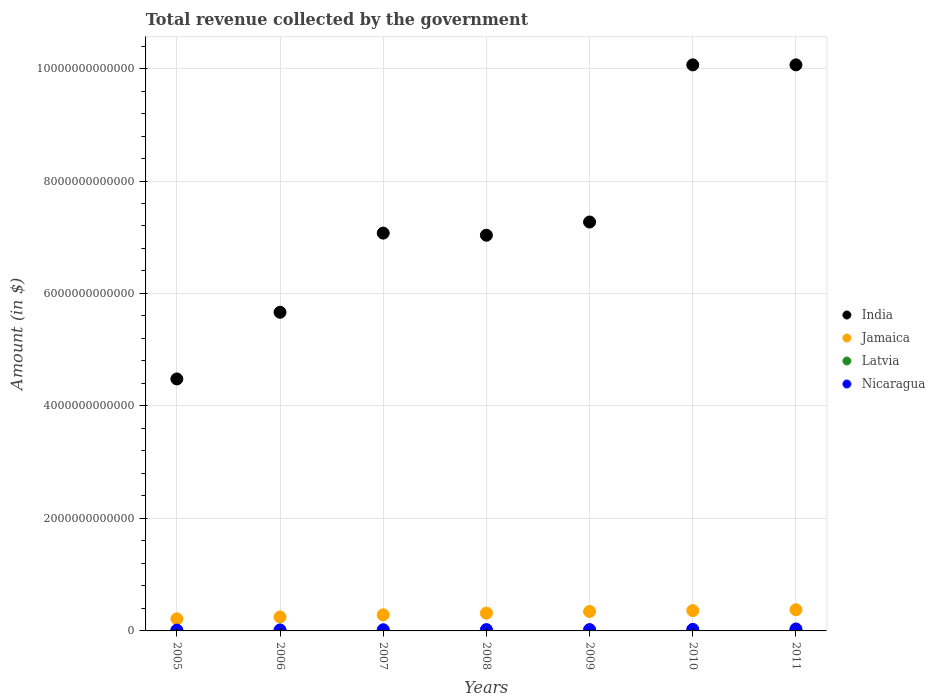Is the number of dotlines equal to the number of legend labels?
Offer a very short reply. Yes. What is the total revenue collected by the government in India in 2007?
Keep it short and to the point. 7.07e+12. Across all years, what is the maximum total revenue collected by the government in India?
Make the answer very short. 1.01e+13. Across all years, what is the minimum total revenue collected by the government in Nicaragua?
Make the answer very short. 1.47e+1. In which year was the total revenue collected by the government in Jamaica maximum?
Your answer should be compact. 2011. In which year was the total revenue collected by the government in India minimum?
Provide a short and direct response. 2005. What is the total total revenue collected by the government in India in the graph?
Ensure brevity in your answer.  5.17e+13. What is the difference between the total revenue collected by the government in Latvia in 2008 and that in 2010?
Provide a succinct answer. 1.04e+09. What is the difference between the total revenue collected by the government in India in 2008 and the total revenue collected by the government in Nicaragua in 2010?
Provide a short and direct response. 7.01e+12. What is the average total revenue collected by the government in India per year?
Ensure brevity in your answer.  7.38e+12. In the year 2011, what is the difference between the total revenue collected by the government in Nicaragua and total revenue collected by the government in Latvia?
Make the answer very short. 3.10e+1. In how many years, is the total revenue collected by the government in Jamaica greater than 6800000000000 $?
Your answer should be very brief. 0. What is the ratio of the total revenue collected by the government in Jamaica in 2005 to that in 2011?
Offer a terse response. 0.57. What is the difference between the highest and the second highest total revenue collected by the government in Nicaragua?
Give a very brief answer. 6.97e+09. What is the difference between the highest and the lowest total revenue collected by the government in India?
Provide a short and direct response. 5.58e+12. In how many years, is the total revenue collected by the government in India greater than the average total revenue collected by the government in India taken over all years?
Offer a very short reply. 2. Is it the case that in every year, the sum of the total revenue collected by the government in Nicaragua and total revenue collected by the government in India  is greater than the total revenue collected by the government in Jamaica?
Ensure brevity in your answer.  Yes. Does the total revenue collected by the government in India monotonically increase over the years?
Ensure brevity in your answer.  No. Is the total revenue collected by the government in Jamaica strictly less than the total revenue collected by the government in Nicaragua over the years?
Provide a short and direct response. No. How many dotlines are there?
Provide a short and direct response. 4. What is the difference between two consecutive major ticks on the Y-axis?
Ensure brevity in your answer.  2.00e+12. Does the graph contain grids?
Ensure brevity in your answer.  Yes. How many legend labels are there?
Offer a very short reply. 4. What is the title of the graph?
Give a very brief answer. Total revenue collected by the government. What is the label or title of the Y-axis?
Ensure brevity in your answer.  Amount (in $). What is the Amount (in $) in India in 2005?
Ensure brevity in your answer.  4.48e+12. What is the Amount (in $) in Jamaica in 2005?
Make the answer very short. 2.15e+11. What is the Amount (in $) in Latvia in 2005?
Your answer should be very brief. 2.38e+09. What is the Amount (in $) in Nicaragua in 2005?
Your answer should be very brief. 1.47e+1. What is the Amount (in $) of India in 2006?
Your answer should be very brief. 5.67e+12. What is the Amount (in $) of Jamaica in 2006?
Ensure brevity in your answer.  2.48e+11. What is the Amount (in $) of Latvia in 2006?
Ensure brevity in your answer.  3.04e+09. What is the Amount (in $) of Nicaragua in 2006?
Your answer should be compact. 1.75e+1. What is the Amount (in $) of India in 2007?
Make the answer very short. 7.07e+12. What is the Amount (in $) of Jamaica in 2007?
Make the answer very short. 2.86e+11. What is the Amount (in $) of Latvia in 2007?
Provide a succinct answer. 3.93e+09. What is the Amount (in $) in Nicaragua in 2007?
Provide a succinct answer. 2.06e+1. What is the Amount (in $) of India in 2008?
Keep it short and to the point. 7.04e+12. What is the Amount (in $) in Jamaica in 2008?
Offer a terse response. 3.16e+11. What is the Amount (in $) of Latvia in 2008?
Make the answer very short. 4.23e+09. What is the Amount (in $) of Nicaragua in 2008?
Provide a succinct answer. 2.35e+1. What is the Amount (in $) in India in 2009?
Ensure brevity in your answer.  7.27e+12. What is the Amount (in $) of Jamaica in 2009?
Provide a succinct answer. 3.46e+11. What is the Amount (in $) in Latvia in 2009?
Offer a terse response. 3.39e+09. What is the Amount (in $) of Nicaragua in 2009?
Your answer should be very brief. 2.39e+1. What is the Amount (in $) in India in 2010?
Your answer should be very brief. 1.01e+13. What is the Amount (in $) in Jamaica in 2010?
Keep it short and to the point. 3.61e+11. What is the Amount (in $) in Latvia in 2010?
Provide a short and direct response. 3.18e+09. What is the Amount (in $) in Nicaragua in 2010?
Your answer should be compact. 2.76e+1. What is the Amount (in $) of India in 2011?
Your response must be concise. 1.01e+13. What is the Amount (in $) of Jamaica in 2011?
Offer a terse response. 3.77e+11. What is the Amount (in $) in Latvia in 2011?
Keep it short and to the point. 3.54e+09. What is the Amount (in $) of Nicaragua in 2011?
Offer a very short reply. 3.45e+1. Across all years, what is the maximum Amount (in $) of India?
Make the answer very short. 1.01e+13. Across all years, what is the maximum Amount (in $) in Jamaica?
Make the answer very short. 3.77e+11. Across all years, what is the maximum Amount (in $) in Latvia?
Provide a succinct answer. 4.23e+09. Across all years, what is the maximum Amount (in $) in Nicaragua?
Your answer should be very brief. 3.45e+1. Across all years, what is the minimum Amount (in $) of India?
Offer a very short reply. 4.48e+12. Across all years, what is the minimum Amount (in $) of Jamaica?
Provide a succinct answer. 2.15e+11. Across all years, what is the minimum Amount (in $) in Latvia?
Provide a succinct answer. 2.38e+09. Across all years, what is the minimum Amount (in $) of Nicaragua?
Your answer should be very brief. 1.47e+1. What is the total Amount (in $) of India in the graph?
Ensure brevity in your answer.  5.17e+13. What is the total Amount (in $) in Jamaica in the graph?
Offer a terse response. 2.15e+12. What is the total Amount (in $) in Latvia in the graph?
Your answer should be very brief. 2.37e+1. What is the total Amount (in $) in Nicaragua in the graph?
Provide a succinct answer. 1.62e+11. What is the difference between the Amount (in $) in India in 2005 and that in 2006?
Give a very brief answer. -1.19e+12. What is the difference between the Amount (in $) of Jamaica in 2005 and that in 2006?
Make the answer very short. -3.33e+1. What is the difference between the Amount (in $) of Latvia in 2005 and that in 2006?
Offer a very short reply. -6.58e+08. What is the difference between the Amount (in $) in Nicaragua in 2005 and that in 2006?
Offer a very short reply. -2.80e+09. What is the difference between the Amount (in $) of India in 2005 and that in 2007?
Provide a short and direct response. -2.59e+12. What is the difference between the Amount (in $) in Jamaica in 2005 and that in 2007?
Ensure brevity in your answer.  -7.11e+1. What is the difference between the Amount (in $) in Latvia in 2005 and that in 2007?
Your response must be concise. -1.55e+09. What is the difference between the Amount (in $) in Nicaragua in 2005 and that in 2007?
Provide a short and direct response. -5.87e+09. What is the difference between the Amount (in $) in India in 2005 and that in 2008?
Offer a terse response. -2.56e+12. What is the difference between the Amount (in $) in Jamaica in 2005 and that in 2008?
Offer a terse response. -1.01e+11. What is the difference between the Amount (in $) of Latvia in 2005 and that in 2008?
Your answer should be very brief. -1.85e+09. What is the difference between the Amount (in $) of Nicaragua in 2005 and that in 2008?
Make the answer very short. -8.76e+09. What is the difference between the Amount (in $) in India in 2005 and that in 2009?
Provide a short and direct response. -2.79e+12. What is the difference between the Amount (in $) of Jamaica in 2005 and that in 2009?
Your answer should be compact. -1.31e+11. What is the difference between the Amount (in $) of Latvia in 2005 and that in 2009?
Make the answer very short. -1.01e+09. What is the difference between the Amount (in $) in Nicaragua in 2005 and that in 2009?
Your answer should be very brief. -9.15e+09. What is the difference between the Amount (in $) in India in 2005 and that in 2010?
Your answer should be compact. -5.58e+12. What is the difference between the Amount (in $) of Jamaica in 2005 and that in 2010?
Provide a succinct answer. -1.46e+11. What is the difference between the Amount (in $) of Latvia in 2005 and that in 2010?
Offer a terse response. -8.04e+08. What is the difference between the Amount (in $) in Nicaragua in 2005 and that in 2010?
Make the answer very short. -1.29e+1. What is the difference between the Amount (in $) of India in 2005 and that in 2011?
Your answer should be compact. -5.58e+12. What is the difference between the Amount (in $) in Jamaica in 2005 and that in 2011?
Offer a very short reply. -1.62e+11. What is the difference between the Amount (in $) of Latvia in 2005 and that in 2011?
Your answer should be very brief. -1.16e+09. What is the difference between the Amount (in $) of Nicaragua in 2005 and that in 2011?
Your answer should be compact. -1.98e+1. What is the difference between the Amount (in $) of India in 2006 and that in 2007?
Keep it short and to the point. -1.41e+12. What is the difference between the Amount (in $) of Jamaica in 2006 and that in 2007?
Provide a succinct answer. -3.78e+1. What is the difference between the Amount (in $) of Latvia in 2006 and that in 2007?
Your response must be concise. -8.90e+08. What is the difference between the Amount (in $) of Nicaragua in 2006 and that in 2007?
Provide a short and direct response. -3.07e+09. What is the difference between the Amount (in $) of India in 2006 and that in 2008?
Keep it short and to the point. -1.37e+12. What is the difference between the Amount (in $) of Jamaica in 2006 and that in 2008?
Your answer should be compact. -6.80e+1. What is the difference between the Amount (in $) of Latvia in 2006 and that in 2008?
Provide a succinct answer. -1.19e+09. What is the difference between the Amount (in $) of Nicaragua in 2006 and that in 2008?
Provide a short and direct response. -5.96e+09. What is the difference between the Amount (in $) of India in 2006 and that in 2009?
Your answer should be compact. -1.60e+12. What is the difference between the Amount (in $) in Jamaica in 2006 and that in 2009?
Offer a very short reply. -9.79e+1. What is the difference between the Amount (in $) in Latvia in 2006 and that in 2009?
Provide a succinct answer. -3.51e+08. What is the difference between the Amount (in $) of Nicaragua in 2006 and that in 2009?
Your answer should be compact. -6.35e+09. What is the difference between the Amount (in $) in India in 2006 and that in 2010?
Provide a short and direct response. -4.40e+12. What is the difference between the Amount (in $) in Jamaica in 2006 and that in 2010?
Your answer should be very brief. -1.13e+11. What is the difference between the Amount (in $) of Latvia in 2006 and that in 2010?
Your answer should be compact. -1.45e+08. What is the difference between the Amount (in $) in Nicaragua in 2006 and that in 2010?
Offer a terse response. -1.01e+1. What is the difference between the Amount (in $) in India in 2006 and that in 2011?
Your response must be concise. -4.40e+12. What is the difference between the Amount (in $) of Jamaica in 2006 and that in 2011?
Provide a short and direct response. -1.29e+11. What is the difference between the Amount (in $) of Latvia in 2006 and that in 2011?
Keep it short and to the point. -5.03e+08. What is the difference between the Amount (in $) of Nicaragua in 2006 and that in 2011?
Provide a succinct answer. -1.70e+1. What is the difference between the Amount (in $) in India in 2007 and that in 2008?
Give a very brief answer. 3.76e+1. What is the difference between the Amount (in $) in Jamaica in 2007 and that in 2008?
Offer a terse response. -3.02e+1. What is the difference between the Amount (in $) in Latvia in 2007 and that in 2008?
Offer a terse response. -2.99e+08. What is the difference between the Amount (in $) of Nicaragua in 2007 and that in 2008?
Your response must be concise. -2.89e+09. What is the difference between the Amount (in $) in India in 2007 and that in 2009?
Your response must be concise. -1.97e+11. What is the difference between the Amount (in $) of Jamaica in 2007 and that in 2009?
Ensure brevity in your answer.  -6.01e+1. What is the difference between the Amount (in $) in Latvia in 2007 and that in 2009?
Your response must be concise. 5.39e+08. What is the difference between the Amount (in $) in Nicaragua in 2007 and that in 2009?
Make the answer very short. -3.28e+09. What is the difference between the Amount (in $) in India in 2007 and that in 2010?
Ensure brevity in your answer.  -2.99e+12. What is the difference between the Amount (in $) of Jamaica in 2007 and that in 2010?
Your answer should be very brief. -7.53e+1. What is the difference between the Amount (in $) in Latvia in 2007 and that in 2010?
Your answer should be compact. 7.45e+08. What is the difference between the Amount (in $) of Nicaragua in 2007 and that in 2010?
Provide a succinct answer. -7.00e+09. What is the difference between the Amount (in $) of India in 2007 and that in 2011?
Provide a short and direct response. -2.99e+12. What is the difference between the Amount (in $) of Jamaica in 2007 and that in 2011?
Your response must be concise. -9.07e+1. What is the difference between the Amount (in $) in Latvia in 2007 and that in 2011?
Provide a succinct answer. 3.87e+08. What is the difference between the Amount (in $) of Nicaragua in 2007 and that in 2011?
Your answer should be very brief. -1.40e+1. What is the difference between the Amount (in $) of India in 2008 and that in 2009?
Your answer should be very brief. -2.35e+11. What is the difference between the Amount (in $) of Jamaica in 2008 and that in 2009?
Make the answer very short. -2.99e+1. What is the difference between the Amount (in $) in Latvia in 2008 and that in 2009?
Your answer should be compact. 8.38e+08. What is the difference between the Amount (in $) of Nicaragua in 2008 and that in 2009?
Provide a short and direct response. -3.91e+08. What is the difference between the Amount (in $) in India in 2008 and that in 2010?
Your answer should be very brief. -3.03e+12. What is the difference between the Amount (in $) in Jamaica in 2008 and that in 2010?
Make the answer very short. -4.51e+1. What is the difference between the Amount (in $) of Latvia in 2008 and that in 2010?
Your answer should be compact. 1.04e+09. What is the difference between the Amount (in $) in Nicaragua in 2008 and that in 2010?
Your answer should be very brief. -4.11e+09. What is the difference between the Amount (in $) in India in 2008 and that in 2011?
Make the answer very short. -3.03e+12. What is the difference between the Amount (in $) of Jamaica in 2008 and that in 2011?
Offer a very short reply. -6.06e+1. What is the difference between the Amount (in $) of Latvia in 2008 and that in 2011?
Make the answer very short. 6.86e+08. What is the difference between the Amount (in $) of Nicaragua in 2008 and that in 2011?
Your response must be concise. -1.11e+1. What is the difference between the Amount (in $) of India in 2009 and that in 2010?
Keep it short and to the point. -2.79e+12. What is the difference between the Amount (in $) in Jamaica in 2009 and that in 2010?
Give a very brief answer. -1.52e+1. What is the difference between the Amount (in $) of Latvia in 2009 and that in 2010?
Your response must be concise. 2.06e+08. What is the difference between the Amount (in $) in Nicaragua in 2009 and that in 2010?
Your response must be concise. -3.72e+09. What is the difference between the Amount (in $) of India in 2009 and that in 2011?
Provide a succinct answer. -2.79e+12. What is the difference between the Amount (in $) in Jamaica in 2009 and that in 2011?
Offer a terse response. -3.07e+1. What is the difference between the Amount (in $) in Latvia in 2009 and that in 2011?
Provide a short and direct response. -1.52e+08. What is the difference between the Amount (in $) of Nicaragua in 2009 and that in 2011?
Provide a succinct answer. -1.07e+1. What is the difference between the Amount (in $) of India in 2010 and that in 2011?
Your answer should be compact. 0. What is the difference between the Amount (in $) of Jamaica in 2010 and that in 2011?
Keep it short and to the point. -1.55e+1. What is the difference between the Amount (in $) in Latvia in 2010 and that in 2011?
Provide a succinct answer. -3.58e+08. What is the difference between the Amount (in $) in Nicaragua in 2010 and that in 2011?
Provide a short and direct response. -6.97e+09. What is the difference between the Amount (in $) of India in 2005 and the Amount (in $) of Jamaica in 2006?
Provide a short and direct response. 4.23e+12. What is the difference between the Amount (in $) of India in 2005 and the Amount (in $) of Latvia in 2006?
Offer a terse response. 4.48e+12. What is the difference between the Amount (in $) of India in 2005 and the Amount (in $) of Nicaragua in 2006?
Provide a succinct answer. 4.46e+12. What is the difference between the Amount (in $) of Jamaica in 2005 and the Amount (in $) of Latvia in 2006?
Provide a short and direct response. 2.12e+11. What is the difference between the Amount (in $) of Jamaica in 2005 and the Amount (in $) of Nicaragua in 2006?
Ensure brevity in your answer.  1.97e+11. What is the difference between the Amount (in $) of Latvia in 2005 and the Amount (in $) of Nicaragua in 2006?
Keep it short and to the point. -1.51e+1. What is the difference between the Amount (in $) of India in 2005 and the Amount (in $) of Jamaica in 2007?
Offer a very short reply. 4.19e+12. What is the difference between the Amount (in $) of India in 2005 and the Amount (in $) of Latvia in 2007?
Your response must be concise. 4.48e+12. What is the difference between the Amount (in $) of India in 2005 and the Amount (in $) of Nicaragua in 2007?
Your answer should be very brief. 4.46e+12. What is the difference between the Amount (in $) in Jamaica in 2005 and the Amount (in $) in Latvia in 2007?
Keep it short and to the point. 2.11e+11. What is the difference between the Amount (in $) in Jamaica in 2005 and the Amount (in $) in Nicaragua in 2007?
Offer a terse response. 1.94e+11. What is the difference between the Amount (in $) of Latvia in 2005 and the Amount (in $) of Nicaragua in 2007?
Keep it short and to the point. -1.82e+1. What is the difference between the Amount (in $) of India in 2005 and the Amount (in $) of Jamaica in 2008?
Ensure brevity in your answer.  4.16e+12. What is the difference between the Amount (in $) in India in 2005 and the Amount (in $) in Latvia in 2008?
Give a very brief answer. 4.48e+12. What is the difference between the Amount (in $) of India in 2005 and the Amount (in $) of Nicaragua in 2008?
Your answer should be compact. 4.46e+12. What is the difference between the Amount (in $) of Jamaica in 2005 and the Amount (in $) of Latvia in 2008?
Provide a short and direct response. 2.11e+11. What is the difference between the Amount (in $) in Jamaica in 2005 and the Amount (in $) in Nicaragua in 2008?
Provide a short and direct response. 1.91e+11. What is the difference between the Amount (in $) in Latvia in 2005 and the Amount (in $) in Nicaragua in 2008?
Your answer should be very brief. -2.11e+1. What is the difference between the Amount (in $) in India in 2005 and the Amount (in $) in Jamaica in 2009?
Your response must be concise. 4.13e+12. What is the difference between the Amount (in $) in India in 2005 and the Amount (in $) in Latvia in 2009?
Ensure brevity in your answer.  4.48e+12. What is the difference between the Amount (in $) in India in 2005 and the Amount (in $) in Nicaragua in 2009?
Give a very brief answer. 4.46e+12. What is the difference between the Amount (in $) of Jamaica in 2005 and the Amount (in $) of Latvia in 2009?
Offer a very short reply. 2.12e+11. What is the difference between the Amount (in $) in Jamaica in 2005 and the Amount (in $) in Nicaragua in 2009?
Keep it short and to the point. 1.91e+11. What is the difference between the Amount (in $) of Latvia in 2005 and the Amount (in $) of Nicaragua in 2009?
Provide a short and direct response. -2.15e+1. What is the difference between the Amount (in $) of India in 2005 and the Amount (in $) of Jamaica in 2010?
Offer a terse response. 4.12e+12. What is the difference between the Amount (in $) in India in 2005 and the Amount (in $) in Latvia in 2010?
Provide a succinct answer. 4.48e+12. What is the difference between the Amount (in $) of India in 2005 and the Amount (in $) of Nicaragua in 2010?
Give a very brief answer. 4.45e+12. What is the difference between the Amount (in $) of Jamaica in 2005 and the Amount (in $) of Latvia in 2010?
Ensure brevity in your answer.  2.12e+11. What is the difference between the Amount (in $) of Jamaica in 2005 and the Amount (in $) of Nicaragua in 2010?
Your answer should be very brief. 1.87e+11. What is the difference between the Amount (in $) of Latvia in 2005 and the Amount (in $) of Nicaragua in 2010?
Your response must be concise. -2.52e+1. What is the difference between the Amount (in $) in India in 2005 and the Amount (in $) in Jamaica in 2011?
Your response must be concise. 4.10e+12. What is the difference between the Amount (in $) in India in 2005 and the Amount (in $) in Latvia in 2011?
Your answer should be compact. 4.48e+12. What is the difference between the Amount (in $) of India in 2005 and the Amount (in $) of Nicaragua in 2011?
Your answer should be compact. 4.45e+12. What is the difference between the Amount (in $) in Jamaica in 2005 and the Amount (in $) in Latvia in 2011?
Provide a short and direct response. 2.11e+11. What is the difference between the Amount (in $) of Jamaica in 2005 and the Amount (in $) of Nicaragua in 2011?
Offer a terse response. 1.80e+11. What is the difference between the Amount (in $) of Latvia in 2005 and the Amount (in $) of Nicaragua in 2011?
Keep it short and to the point. -3.22e+1. What is the difference between the Amount (in $) of India in 2006 and the Amount (in $) of Jamaica in 2007?
Offer a very short reply. 5.38e+12. What is the difference between the Amount (in $) in India in 2006 and the Amount (in $) in Latvia in 2007?
Give a very brief answer. 5.66e+12. What is the difference between the Amount (in $) of India in 2006 and the Amount (in $) of Nicaragua in 2007?
Provide a succinct answer. 5.65e+12. What is the difference between the Amount (in $) of Jamaica in 2006 and the Amount (in $) of Latvia in 2007?
Provide a succinct answer. 2.44e+11. What is the difference between the Amount (in $) of Jamaica in 2006 and the Amount (in $) of Nicaragua in 2007?
Provide a short and direct response. 2.28e+11. What is the difference between the Amount (in $) in Latvia in 2006 and the Amount (in $) in Nicaragua in 2007?
Your answer should be compact. -1.75e+1. What is the difference between the Amount (in $) in India in 2006 and the Amount (in $) in Jamaica in 2008?
Make the answer very short. 5.35e+12. What is the difference between the Amount (in $) of India in 2006 and the Amount (in $) of Latvia in 2008?
Provide a short and direct response. 5.66e+12. What is the difference between the Amount (in $) in India in 2006 and the Amount (in $) in Nicaragua in 2008?
Make the answer very short. 5.64e+12. What is the difference between the Amount (in $) in Jamaica in 2006 and the Amount (in $) in Latvia in 2008?
Keep it short and to the point. 2.44e+11. What is the difference between the Amount (in $) of Jamaica in 2006 and the Amount (in $) of Nicaragua in 2008?
Give a very brief answer. 2.25e+11. What is the difference between the Amount (in $) in Latvia in 2006 and the Amount (in $) in Nicaragua in 2008?
Provide a short and direct response. -2.04e+1. What is the difference between the Amount (in $) of India in 2006 and the Amount (in $) of Jamaica in 2009?
Offer a terse response. 5.32e+12. What is the difference between the Amount (in $) in India in 2006 and the Amount (in $) in Latvia in 2009?
Your answer should be compact. 5.66e+12. What is the difference between the Amount (in $) of India in 2006 and the Amount (in $) of Nicaragua in 2009?
Offer a terse response. 5.64e+12. What is the difference between the Amount (in $) in Jamaica in 2006 and the Amount (in $) in Latvia in 2009?
Ensure brevity in your answer.  2.45e+11. What is the difference between the Amount (in $) in Jamaica in 2006 and the Amount (in $) in Nicaragua in 2009?
Offer a terse response. 2.24e+11. What is the difference between the Amount (in $) in Latvia in 2006 and the Amount (in $) in Nicaragua in 2009?
Your answer should be very brief. -2.08e+1. What is the difference between the Amount (in $) of India in 2006 and the Amount (in $) of Jamaica in 2010?
Your answer should be very brief. 5.30e+12. What is the difference between the Amount (in $) of India in 2006 and the Amount (in $) of Latvia in 2010?
Offer a terse response. 5.66e+12. What is the difference between the Amount (in $) of India in 2006 and the Amount (in $) of Nicaragua in 2010?
Offer a terse response. 5.64e+12. What is the difference between the Amount (in $) of Jamaica in 2006 and the Amount (in $) of Latvia in 2010?
Your answer should be compact. 2.45e+11. What is the difference between the Amount (in $) in Jamaica in 2006 and the Amount (in $) in Nicaragua in 2010?
Provide a succinct answer. 2.21e+11. What is the difference between the Amount (in $) of Latvia in 2006 and the Amount (in $) of Nicaragua in 2010?
Provide a short and direct response. -2.45e+1. What is the difference between the Amount (in $) of India in 2006 and the Amount (in $) of Jamaica in 2011?
Keep it short and to the point. 5.29e+12. What is the difference between the Amount (in $) in India in 2006 and the Amount (in $) in Latvia in 2011?
Your answer should be very brief. 5.66e+12. What is the difference between the Amount (in $) in India in 2006 and the Amount (in $) in Nicaragua in 2011?
Provide a short and direct response. 5.63e+12. What is the difference between the Amount (in $) in Jamaica in 2006 and the Amount (in $) in Latvia in 2011?
Provide a short and direct response. 2.45e+11. What is the difference between the Amount (in $) in Jamaica in 2006 and the Amount (in $) in Nicaragua in 2011?
Your response must be concise. 2.14e+11. What is the difference between the Amount (in $) in Latvia in 2006 and the Amount (in $) in Nicaragua in 2011?
Give a very brief answer. -3.15e+1. What is the difference between the Amount (in $) of India in 2007 and the Amount (in $) of Jamaica in 2008?
Offer a very short reply. 6.76e+12. What is the difference between the Amount (in $) of India in 2007 and the Amount (in $) of Latvia in 2008?
Ensure brevity in your answer.  7.07e+12. What is the difference between the Amount (in $) in India in 2007 and the Amount (in $) in Nicaragua in 2008?
Provide a succinct answer. 7.05e+12. What is the difference between the Amount (in $) of Jamaica in 2007 and the Amount (in $) of Latvia in 2008?
Offer a terse response. 2.82e+11. What is the difference between the Amount (in $) of Jamaica in 2007 and the Amount (in $) of Nicaragua in 2008?
Your answer should be compact. 2.63e+11. What is the difference between the Amount (in $) of Latvia in 2007 and the Amount (in $) of Nicaragua in 2008?
Provide a short and direct response. -1.95e+1. What is the difference between the Amount (in $) in India in 2007 and the Amount (in $) in Jamaica in 2009?
Keep it short and to the point. 6.73e+12. What is the difference between the Amount (in $) in India in 2007 and the Amount (in $) in Latvia in 2009?
Your answer should be very brief. 7.07e+12. What is the difference between the Amount (in $) of India in 2007 and the Amount (in $) of Nicaragua in 2009?
Provide a short and direct response. 7.05e+12. What is the difference between the Amount (in $) in Jamaica in 2007 and the Amount (in $) in Latvia in 2009?
Make the answer very short. 2.83e+11. What is the difference between the Amount (in $) in Jamaica in 2007 and the Amount (in $) in Nicaragua in 2009?
Make the answer very short. 2.62e+11. What is the difference between the Amount (in $) in Latvia in 2007 and the Amount (in $) in Nicaragua in 2009?
Provide a succinct answer. -1.99e+1. What is the difference between the Amount (in $) in India in 2007 and the Amount (in $) in Jamaica in 2010?
Your answer should be very brief. 6.71e+12. What is the difference between the Amount (in $) in India in 2007 and the Amount (in $) in Latvia in 2010?
Provide a succinct answer. 7.07e+12. What is the difference between the Amount (in $) in India in 2007 and the Amount (in $) in Nicaragua in 2010?
Your answer should be very brief. 7.05e+12. What is the difference between the Amount (in $) of Jamaica in 2007 and the Amount (in $) of Latvia in 2010?
Keep it short and to the point. 2.83e+11. What is the difference between the Amount (in $) of Jamaica in 2007 and the Amount (in $) of Nicaragua in 2010?
Your response must be concise. 2.58e+11. What is the difference between the Amount (in $) of Latvia in 2007 and the Amount (in $) of Nicaragua in 2010?
Give a very brief answer. -2.36e+1. What is the difference between the Amount (in $) of India in 2007 and the Amount (in $) of Jamaica in 2011?
Offer a very short reply. 6.70e+12. What is the difference between the Amount (in $) in India in 2007 and the Amount (in $) in Latvia in 2011?
Your response must be concise. 7.07e+12. What is the difference between the Amount (in $) of India in 2007 and the Amount (in $) of Nicaragua in 2011?
Offer a terse response. 7.04e+12. What is the difference between the Amount (in $) in Jamaica in 2007 and the Amount (in $) in Latvia in 2011?
Your answer should be compact. 2.83e+11. What is the difference between the Amount (in $) in Jamaica in 2007 and the Amount (in $) in Nicaragua in 2011?
Offer a very short reply. 2.52e+11. What is the difference between the Amount (in $) in Latvia in 2007 and the Amount (in $) in Nicaragua in 2011?
Your answer should be very brief. -3.06e+1. What is the difference between the Amount (in $) of India in 2008 and the Amount (in $) of Jamaica in 2009?
Your response must be concise. 6.69e+12. What is the difference between the Amount (in $) in India in 2008 and the Amount (in $) in Latvia in 2009?
Provide a succinct answer. 7.03e+12. What is the difference between the Amount (in $) in India in 2008 and the Amount (in $) in Nicaragua in 2009?
Your response must be concise. 7.01e+12. What is the difference between the Amount (in $) in Jamaica in 2008 and the Amount (in $) in Latvia in 2009?
Ensure brevity in your answer.  3.13e+11. What is the difference between the Amount (in $) of Jamaica in 2008 and the Amount (in $) of Nicaragua in 2009?
Your answer should be very brief. 2.92e+11. What is the difference between the Amount (in $) in Latvia in 2008 and the Amount (in $) in Nicaragua in 2009?
Keep it short and to the point. -1.96e+1. What is the difference between the Amount (in $) in India in 2008 and the Amount (in $) in Jamaica in 2010?
Offer a terse response. 6.67e+12. What is the difference between the Amount (in $) in India in 2008 and the Amount (in $) in Latvia in 2010?
Your answer should be compact. 7.03e+12. What is the difference between the Amount (in $) in India in 2008 and the Amount (in $) in Nicaragua in 2010?
Your answer should be very brief. 7.01e+12. What is the difference between the Amount (in $) of Jamaica in 2008 and the Amount (in $) of Latvia in 2010?
Give a very brief answer. 3.13e+11. What is the difference between the Amount (in $) in Jamaica in 2008 and the Amount (in $) in Nicaragua in 2010?
Keep it short and to the point. 2.89e+11. What is the difference between the Amount (in $) of Latvia in 2008 and the Amount (in $) of Nicaragua in 2010?
Give a very brief answer. -2.33e+1. What is the difference between the Amount (in $) of India in 2008 and the Amount (in $) of Jamaica in 2011?
Offer a terse response. 6.66e+12. What is the difference between the Amount (in $) in India in 2008 and the Amount (in $) in Latvia in 2011?
Your answer should be very brief. 7.03e+12. What is the difference between the Amount (in $) in India in 2008 and the Amount (in $) in Nicaragua in 2011?
Make the answer very short. 7.00e+12. What is the difference between the Amount (in $) of Jamaica in 2008 and the Amount (in $) of Latvia in 2011?
Your response must be concise. 3.13e+11. What is the difference between the Amount (in $) of Jamaica in 2008 and the Amount (in $) of Nicaragua in 2011?
Offer a terse response. 2.82e+11. What is the difference between the Amount (in $) in Latvia in 2008 and the Amount (in $) in Nicaragua in 2011?
Ensure brevity in your answer.  -3.03e+1. What is the difference between the Amount (in $) of India in 2009 and the Amount (in $) of Jamaica in 2010?
Give a very brief answer. 6.91e+12. What is the difference between the Amount (in $) of India in 2009 and the Amount (in $) of Latvia in 2010?
Ensure brevity in your answer.  7.27e+12. What is the difference between the Amount (in $) in India in 2009 and the Amount (in $) in Nicaragua in 2010?
Your answer should be very brief. 7.24e+12. What is the difference between the Amount (in $) of Jamaica in 2009 and the Amount (in $) of Latvia in 2010?
Provide a short and direct response. 3.43e+11. What is the difference between the Amount (in $) in Jamaica in 2009 and the Amount (in $) in Nicaragua in 2010?
Offer a terse response. 3.19e+11. What is the difference between the Amount (in $) of Latvia in 2009 and the Amount (in $) of Nicaragua in 2010?
Give a very brief answer. -2.42e+1. What is the difference between the Amount (in $) of India in 2009 and the Amount (in $) of Jamaica in 2011?
Your answer should be very brief. 6.89e+12. What is the difference between the Amount (in $) in India in 2009 and the Amount (in $) in Latvia in 2011?
Make the answer very short. 7.27e+12. What is the difference between the Amount (in $) of India in 2009 and the Amount (in $) of Nicaragua in 2011?
Provide a short and direct response. 7.24e+12. What is the difference between the Amount (in $) of Jamaica in 2009 and the Amount (in $) of Latvia in 2011?
Keep it short and to the point. 3.43e+11. What is the difference between the Amount (in $) in Jamaica in 2009 and the Amount (in $) in Nicaragua in 2011?
Offer a very short reply. 3.12e+11. What is the difference between the Amount (in $) in Latvia in 2009 and the Amount (in $) in Nicaragua in 2011?
Ensure brevity in your answer.  -3.12e+1. What is the difference between the Amount (in $) of India in 2010 and the Amount (in $) of Jamaica in 2011?
Give a very brief answer. 9.69e+12. What is the difference between the Amount (in $) of India in 2010 and the Amount (in $) of Latvia in 2011?
Offer a very short reply. 1.01e+13. What is the difference between the Amount (in $) of India in 2010 and the Amount (in $) of Nicaragua in 2011?
Your answer should be very brief. 1.00e+13. What is the difference between the Amount (in $) in Jamaica in 2010 and the Amount (in $) in Latvia in 2011?
Make the answer very short. 3.58e+11. What is the difference between the Amount (in $) in Jamaica in 2010 and the Amount (in $) in Nicaragua in 2011?
Offer a very short reply. 3.27e+11. What is the difference between the Amount (in $) of Latvia in 2010 and the Amount (in $) of Nicaragua in 2011?
Ensure brevity in your answer.  -3.14e+1. What is the average Amount (in $) in India per year?
Give a very brief answer. 7.38e+12. What is the average Amount (in $) of Jamaica per year?
Ensure brevity in your answer.  3.07e+11. What is the average Amount (in $) in Latvia per year?
Your answer should be compact. 3.38e+09. What is the average Amount (in $) of Nicaragua per year?
Ensure brevity in your answer.  2.32e+1. In the year 2005, what is the difference between the Amount (in $) in India and Amount (in $) in Jamaica?
Provide a succinct answer. 4.27e+12. In the year 2005, what is the difference between the Amount (in $) of India and Amount (in $) of Latvia?
Provide a short and direct response. 4.48e+12. In the year 2005, what is the difference between the Amount (in $) of India and Amount (in $) of Nicaragua?
Your answer should be very brief. 4.47e+12. In the year 2005, what is the difference between the Amount (in $) in Jamaica and Amount (in $) in Latvia?
Your answer should be very brief. 2.13e+11. In the year 2005, what is the difference between the Amount (in $) in Jamaica and Amount (in $) in Nicaragua?
Your answer should be compact. 2.00e+11. In the year 2005, what is the difference between the Amount (in $) of Latvia and Amount (in $) of Nicaragua?
Your response must be concise. -1.23e+1. In the year 2006, what is the difference between the Amount (in $) of India and Amount (in $) of Jamaica?
Provide a succinct answer. 5.42e+12. In the year 2006, what is the difference between the Amount (in $) of India and Amount (in $) of Latvia?
Make the answer very short. 5.66e+12. In the year 2006, what is the difference between the Amount (in $) in India and Amount (in $) in Nicaragua?
Provide a short and direct response. 5.65e+12. In the year 2006, what is the difference between the Amount (in $) of Jamaica and Amount (in $) of Latvia?
Offer a terse response. 2.45e+11. In the year 2006, what is the difference between the Amount (in $) in Jamaica and Amount (in $) in Nicaragua?
Offer a very short reply. 2.31e+11. In the year 2006, what is the difference between the Amount (in $) in Latvia and Amount (in $) in Nicaragua?
Your answer should be very brief. -1.45e+1. In the year 2007, what is the difference between the Amount (in $) in India and Amount (in $) in Jamaica?
Your answer should be compact. 6.79e+12. In the year 2007, what is the difference between the Amount (in $) in India and Amount (in $) in Latvia?
Your response must be concise. 7.07e+12. In the year 2007, what is the difference between the Amount (in $) in India and Amount (in $) in Nicaragua?
Provide a succinct answer. 7.05e+12. In the year 2007, what is the difference between the Amount (in $) of Jamaica and Amount (in $) of Latvia?
Offer a very short reply. 2.82e+11. In the year 2007, what is the difference between the Amount (in $) in Jamaica and Amount (in $) in Nicaragua?
Your answer should be compact. 2.65e+11. In the year 2007, what is the difference between the Amount (in $) in Latvia and Amount (in $) in Nicaragua?
Your answer should be compact. -1.67e+1. In the year 2008, what is the difference between the Amount (in $) of India and Amount (in $) of Jamaica?
Give a very brief answer. 6.72e+12. In the year 2008, what is the difference between the Amount (in $) in India and Amount (in $) in Latvia?
Provide a succinct answer. 7.03e+12. In the year 2008, what is the difference between the Amount (in $) of India and Amount (in $) of Nicaragua?
Offer a very short reply. 7.01e+12. In the year 2008, what is the difference between the Amount (in $) in Jamaica and Amount (in $) in Latvia?
Your response must be concise. 3.12e+11. In the year 2008, what is the difference between the Amount (in $) in Jamaica and Amount (in $) in Nicaragua?
Keep it short and to the point. 2.93e+11. In the year 2008, what is the difference between the Amount (in $) of Latvia and Amount (in $) of Nicaragua?
Your answer should be compact. -1.92e+1. In the year 2009, what is the difference between the Amount (in $) of India and Amount (in $) of Jamaica?
Offer a very short reply. 6.92e+12. In the year 2009, what is the difference between the Amount (in $) in India and Amount (in $) in Latvia?
Offer a very short reply. 7.27e+12. In the year 2009, what is the difference between the Amount (in $) of India and Amount (in $) of Nicaragua?
Provide a short and direct response. 7.25e+12. In the year 2009, what is the difference between the Amount (in $) of Jamaica and Amount (in $) of Latvia?
Give a very brief answer. 3.43e+11. In the year 2009, what is the difference between the Amount (in $) in Jamaica and Amount (in $) in Nicaragua?
Keep it short and to the point. 3.22e+11. In the year 2009, what is the difference between the Amount (in $) in Latvia and Amount (in $) in Nicaragua?
Give a very brief answer. -2.05e+1. In the year 2010, what is the difference between the Amount (in $) in India and Amount (in $) in Jamaica?
Your response must be concise. 9.70e+12. In the year 2010, what is the difference between the Amount (in $) of India and Amount (in $) of Latvia?
Make the answer very short. 1.01e+13. In the year 2010, what is the difference between the Amount (in $) of India and Amount (in $) of Nicaragua?
Make the answer very short. 1.00e+13. In the year 2010, what is the difference between the Amount (in $) in Jamaica and Amount (in $) in Latvia?
Provide a succinct answer. 3.58e+11. In the year 2010, what is the difference between the Amount (in $) of Jamaica and Amount (in $) of Nicaragua?
Keep it short and to the point. 3.34e+11. In the year 2010, what is the difference between the Amount (in $) of Latvia and Amount (in $) of Nicaragua?
Offer a terse response. -2.44e+1. In the year 2011, what is the difference between the Amount (in $) in India and Amount (in $) in Jamaica?
Your response must be concise. 9.69e+12. In the year 2011, what is the difference between the Amount (in $) of India and Amount (in $) of Latvia?
Provide a short and direct response. 1.01e+13. In the year 2011, what is the difference between the Amount (in $) of India and Amount (in $) of Nicaragua?
Give a very brief answer. 1.00e+13. In the year 2011, what is the difference between the Amount (in $) of Jamaica and Amount (in $) of Latvia?
Keep it short and to the point. 3.73e+11. In the year 2011, what is the difference between the Amount (in $) in Jamaica and Amount (in $) in Nicaragua?
Provide a short and direct response. 3.42e+11. In the year 2011, what is the difference between the Amount (in $) in Latvia and Amount (in $) in Nicaragua?
Provide a short and direct response. -3.10e+1. What is the ratio of the Amount (in $) of India in 2005 to that in 2006?
Your answer should be compact. 0.79. What is the ratio of the Amount (in $) in Jamaica in 2005 to that in 2006?
Offer a terse response. 0.87. What is the ratio of the Amount (in $) in Latvia in 2005 to that in 2006?
Your answer should be very brief. 0.78. What is the ratio of the Amount (in $) in Nicaragua in 2005 to that in 2006?
Keep it short and to the point. 0.84. What is the ratio of the Amount (in $) in India in 2005 to that in 2007?
Give a very brief answer. 0.63. What is the ratio of the Amount (in $) in Jamaica in 2005 to that in 2007?
Offer a terse response. 0.75. What is the ratio of the Amount (in $) of Latvia in 2005 to that in 2007?
Give a very brief answer. 0.61. What is the ratio of the Amount (in $) in Nicaragua in 2005 to that in 2007?
Provide a succinct answer. 0.71. What is the ratio of the Amount (in $) in India in 2005 to that in 2008?
Your answer should be compact. 0.64. What is the ratio of the Amount (in $) in Jamaica in 2005 to that in 2008?
Make the answer very short. 0.68. What is the ratio of the Amount (in $) of Latvia in 2005 to that in 2008?
Give a very brief answer. 0.56. What is the ratio of the Amount (in $) of Nicaragua in 2005 to that in 2008?
Your answer should be very brief. 0.63. What is the ratio of the Amount (in $) in India in 2005 to that in 2009?
Ensure brevity in your answer.  0.62. What is the ratio of the Amount (in $) in Jamaica in 2005 to that in 2009?
Give a very brief answer. 0.62. What is the ratio of the Amount (in $) in Latvia in 2005 to that in 2009?
Make the answer very short. 0.7. What is the ratio of the Amount (in $) in Nicaragua in 2005 to that in 2009?
Offer a very short reply. 0.62. What is the ratio of the Amount (in $) of India in 2005 to that in 2010?
Keep it short and to the point. 0.45. What is the ratio of the Amount (in $) of Jamaica in 2005 to that in 2010?
Offer a terse response. 0.59. What is the ratio of the Amount (in $) in Latvia in 2005 to that in 2010?
Give a very brief answer. 0.75. What is the ratio of the Amount (in $) in Nicaragua in 2005 to that in 2010?
Your answer should be very brief. 0.53. What is the ratio of the Amount (in $) of India in 2005 to that in 2011?
Give a very brief answer. 0.45. What is the ratio of the Amount (in $) of Jamaica in 2005 to that in 2011?
Your answer should be very brief. 0.57. What is the ratio of the Amount (in $) in Latvia in 2005 to that in 2011?
Give a very brief answer. 0.67. What is the ratio of the Amount (in $) of Nicaragua in 2005 to that in 2011?
Offer a very short reply. 0.43. What is the ratio of the Amount (in $) of India in 2006 to that in 2007?
Offer a terse response. 0.8. What is the ratio of the Amount (in $) of Jamaica in 2006 to that in 2007?
Make the answer very short. 0.87. What is the ratio of the Amount (in $) of Latvia in 2006 to that in 2007?
Give a very brief answer. 0.77. What is the ratio of the Amount (in $) of Nicaragua in 2006 to that in 2007?
Make the answer very short. 0.85. What is the ratio of the Amount (in $) of India in 2006 to that in 2008?
Ensure brevity in your answer.  0.81. What is the ratio of the Amount (in $) in Jamaica in 2006 to that in 2008?
Your response must be concise. 0.78. What is the ratio of the Amount (in $) of Latvia in 2006 to that in 2008?
Ensure brevity in your answer.  0.72. What is the ratio of the Amount (in $) of Nicaragua in 2006 to that in 2008?
Keep it short and to the point. 0.75. What is the ratio of the Amount (in $) in India in 2006 to that in 2009?
Provide a succinct answer. 0.78. What is the ratio of the Amount (in $) in Jamaica in 2006 to that in 2009?
Your response must be concise. 0.72. What is the ratio of the Amount (in $) of Latvia in 2006 to that in 2009?
Provide a succinct answer. 0.9. What is the ratio of the Amount (in $) in Nicaragua in 2006 to that in 2009?
Ensure brevity in your answer.  0.73. What is the ratio of the Amount (in $) of India in 2006 to that in 2010?
Offer a terse response. 0.56. What is the ratio of the Amount (in $) of Jamaica in 2006 to that in 2010?
Provide a short and direct response. 0.69. What is the ratio of the Amount (in $) in Latvia in 2006 to that in 2010?
Offer a very short reply. 0.95. What is the ratio of the Amount (in $) of Nicaragua in 2006 to that in 2010?
Provide a succinct answer. 0.64. What is the ratio of the Amount (in $) of India in 2006 to that in 2011?
Your response must be concise. 0.56. What is the ratio of the Amount (in $) in Jamaica in 2006 to that in 2011?
Your answer should be very brief. 0.66. What is the ratio of the Amount (in $) in Latvia in 2006 to that in 2011?
Offer a very short reply. 0.86. What is the ratio of the Amount (in $) of Nicaragua in 2006 to that in 2011?
Your answer should be very brief. 0.51. What is the ratio of the Amount (in $) of India in 2007 to that in 2008?
Provide a succinct answer. 1.01. What is the ratio of the Amount (in $) in Jamaica in 2007 to that in 2008?
Make the answer very short. 0.9. What is the ratio of the Amount (in $) in Latvia in 2007 to that in 2008?
Give a very brief answer. 0.93. What is the ratio of the Amount (in $) in Nicaragua in 2007 to that in 2008?
Your response must be concise. 0.88. What is the ratio of the Amount (in $) of India in 2007 to that in 2009?
Your response must be concise. 0.97. What is the ratio of the Amount (in $) in Jamaica in 2007 to that in 2009?
Offer a terse response. 0.83. What is the ratio of the Amount (in $) of Latvia in 2007 to that in 2009?
Offer a terse response. 1.16. What is the ratio of the Amount (in $) in Nicaragua in 2007 to that in 2009?
Ensure brevity in your answer.  0.86. What is the ratio of the Amount (in $) in India in 2007 to that in 2010?
Offer a terse response. 0.7. What is the ratio of the Amount (in $) in Jamaica in 2007 to that in 2010?
Keep it short and to the point. 0.79. What is the ratio of the Amount (in $) of Latvia in 2007 to that in 2010?
Make the answer very short. 1.23. What is the ratio of the Amount (in $) in Nicaragua in 2007 to that in 2010?
Your response must be concise. 0.75. What is the ratio of the Amount (in $) of India in 2007 to that in 2011?
Keep it short and to the point. 0.7. What is the ratio of the Amount (in $) in Jamaica in 2007 to that in 2011?
Provide a short and direct response. 0.76. What is the ratio of the Amount (in $) in Latvia in 2007 to that in 2011?
Offer a terse response. 1.11. What is the ratio of the Amount (in $) of Nicaragua in 2007 to that in 2011?
Your response must be concise. 0.6. What is the ratio of the Amount (in $) in India in 2008 to that in 2009?
Keep it short and to the point. 0.97. What is the ratio of the Amount (in $) in Jamaica in 2008 to that in 2009?
Ensure brevity in your answer.  0.91. What is the ratio of the Amount (in $) of Latvia in 2008 to that in 2009?
Offer a terse response. 1.25. What is the ratio of the Amount (in $) in Nicaragua in 2008 to that in 2009?
Ensure brevity in your answer.  0.98. What is the ratio of the Amount (in $) of India in 2008 to that in 2010?
Offer a terse response. 0.7. What is the ratio of the Amount (in $) in Jamaica in 2008 to that in 2010?
Provide a short and direct response. 0.88. What is the ratio of the Amount (in $) in Latvia in 2008 to that in 2010?
Your answer should be compact. 1.33. What is the ratio of the Amount (in $) in Nicaragua in 2008 to that in 2010?
Give a very brief answer. 0.85. What is the ratio of the Amount (in $) of India in 2008 to that in 2011?
Your answer should be compact. 0.7. What is the ratio of the Amount (in $) in Jamaica in 2008 to that in 2011?
Your answer should be compact. 0.84. What is the ratio of the Amount (in $) in Latvia in 2008 to that in 2011?
Ensure brevity in your answer.  1.19. What is the ratio of the Amount (in $) in Nicaragua in 2008 to that in 2011?
Offer a very short reply. 0.68. What is the ratio of the Amount (in $) in India in 2009 to that in 2010?
Make the answer very short. 0.72. What is the ratio of the Amount (in $) of Jamaica in 2009 to that in 2010?
Your answer should be very brief. 0.96. What is the ratio of the Amount (in $) in Latvia in 2009 to that in 2010?
Provide a short and direct response. 1.06. What is the ratio of the Amount (in $) of Nicaragua in 2009 to that in 2010?
Keep it short and to the point. 0.87. What is the ratio of the Amount (in $) in India in 2009 to that in 2011?
Your answer should be compact. 0.72. What is the ratio of the Amount (in $) of Jamaica in 2009 to that in 2011?
Make the answer very short. 0.92. What is the ratio of the Amount (in $) in Latvia in 2009 to that in 2011?
Your answer should be very brief. 0.96. What is the ratio of the Amount (in $) of Nicaragua in 2009 to that in 2011?
Ensure brevity in your answer.  0.69. What is the ratio of the Amount (in $) in Latvia in 2010 to that in 2011?
Provide a short and direct response. 0.9. What is the ratio of the Amount (in $) of Nicaragua in 2010 to that in 2011?
Offer a terse response. 0.8. What is the difference between the highest and the second highest Amount (in $) in Jamaica?
Make the answer very short. 1.55e+1. What is the difference between the highest and the second highest Amount (in $) of Latvia?
Provide a short and direct response. 2.99e+08. What is the difference between the highest and the second highest Amount (in $) in Nicaragua?
Your answer should be very brief. 6.97e+09. What is the difference between the highest and the lowest Amount (in $) of India?
Give a very brief answer. 5.58e+12. What is the difference between the highest and the lowest Amount (in $) in Jamaica?
Ensure brevity in your answer.  1.62e+11. What is the difference between the highest and the lowest Amount (in $) in Latvia?
Provide a succinct answer. 1.85e+09. What is the difference between the highest and the lowest Amount (in $) of Nicaragua?
Ensure brevity in your answer.  1.98e+1. 